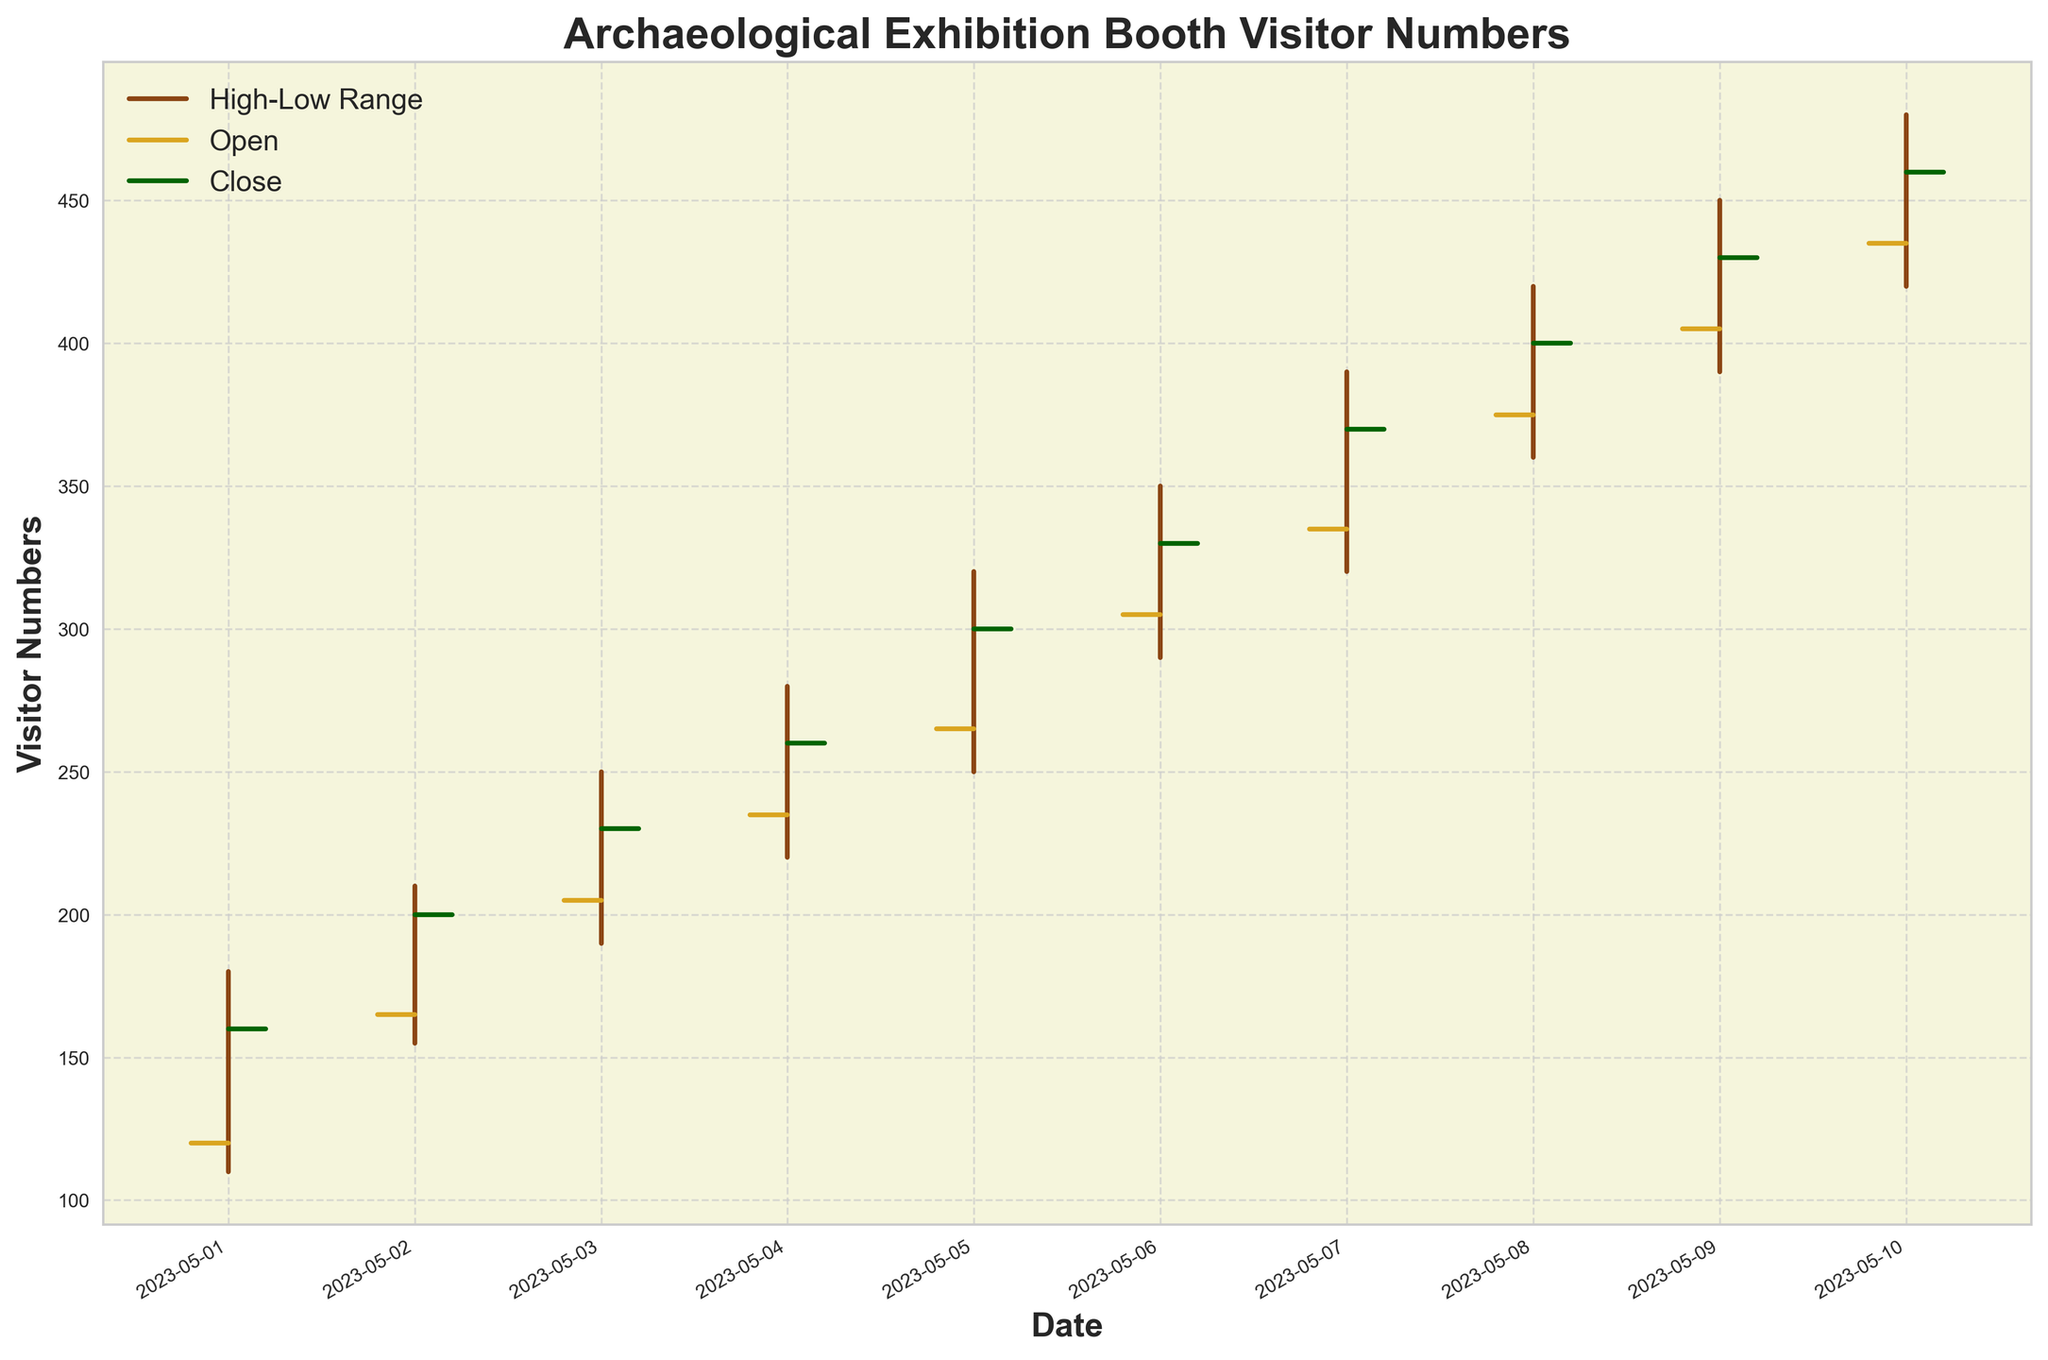What's the title of the figure? Look at the top part of the figure where the title is usually located. The title provides a summary of what the graph is showing.
Answer: Archaeological Exhibition Booth Visitor Numbers How many days does the chart cover? Count the number of days displayed on the x-axis, from the first date to the last date. This gives the total span of the chart.
Answer: 10 On which date did the Close value reach 400? Check the y-axis values and find the label "Close" with the value 400, then follow it to the corresponding date on the x-axis.
Answer: 2023-05-08 What is the highest visitor number recorded and when did it occur? Identify the highest point on the y-axis (High values) and match it with the corresponding date on the x-axis.
Answer: 450 on 2023-05-09 What is the range of visitor numbers for 2023-05-05? Look at the "High" and "Low" values for 2023-05-05 and calculate the difference between them.
Answer: 70 On which date was the open value higher than the close value? Compare the open and close values for each date (yellow tick for open, green tick for close) and find any day where the open tick is higher than the close tick.
Answer: None Which day had the largest difference between the open and close values, and what is that difference? Calculate the difference (Close - Open) for each day and identify the maximum difference.
Answer: 2023-05-06 with a difference of 25 What pattern do you observe in the visitor number trends over the 10 days? Look at the overall shape of the chart to describe trends, such as increasing, decreasing, or fluctuating patterns in the data.
Answer: An increasing trend in visitor numbers Are there any outliers in the data? If so, where? Look for any data point that significantly deviates from the general pattern in the chart (data points much higher or lower than others).
Answer: No significant outliers How does the visitor number range on 2023-05-01 compare to that on 2023-05-10? Compare the high and low values for both dates to determine the differences in range.
Answer: 2023-05-01 range: 70, 2023-05-10 range: 60 